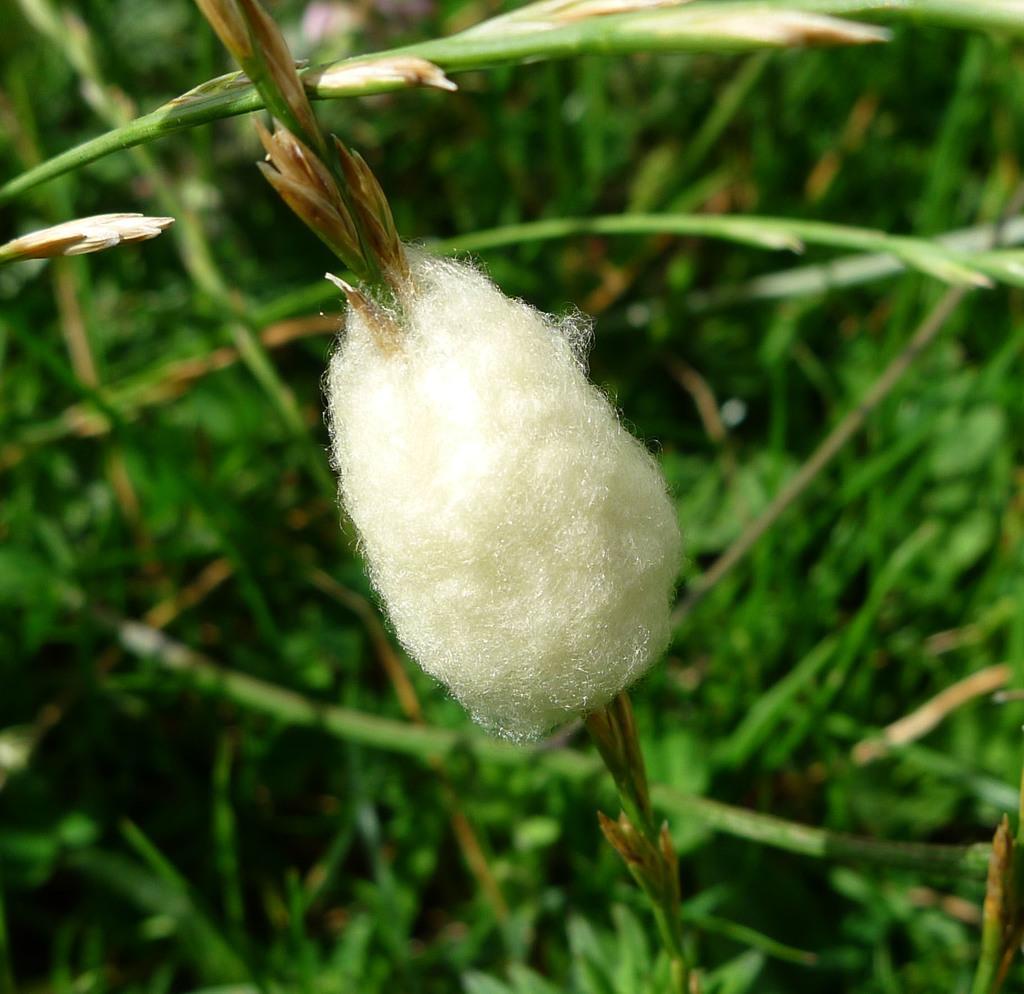In one or two sentences, can you explain what this image depicts? In this image we can see a cocoon to the stem of a plant. 